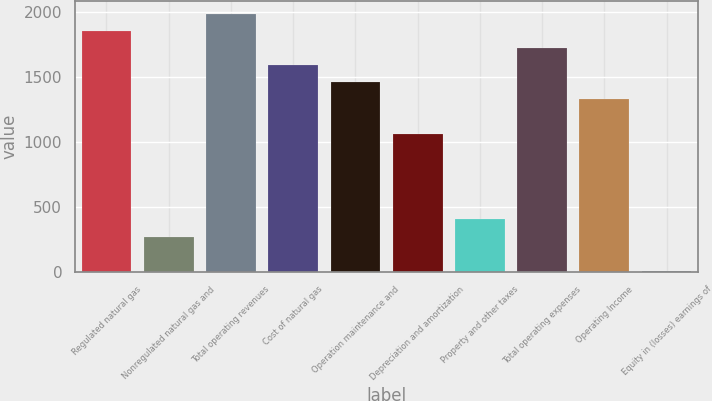Convert chart. <chart><loc_0><loc_0><loc_500><loc_500><bar_chart><fcel>Regulated natural gas<fcel>Nonregulated natural gas and<fcel>Total operating revenues<fcel>Cost of natural gas<fcel>Operation maintenance and<fcel>Depreciation and amortization<fcel>Property and other taxes<fcel>Total operating expenses<fcel>Operating Income<fcel>Equity in (losses) earnings of<nl><fcel>1856.8<fcel>270.4<fcel>1989<fcel>1592.4<fcel>1460.2<fcel>1063.6<fcel>402.6<fcel>1724.6<fcel>1328<fcel>6<nl></chart> 